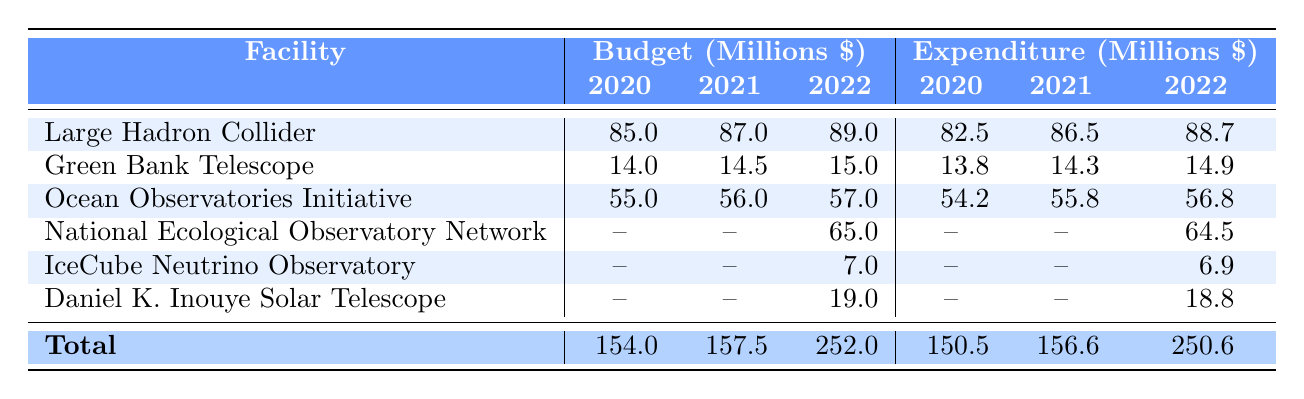What is the budget for the Large Hadron Collider in 2021? The table indicates that the budget for the Large Hadron Collider in 2021 is listed in the corresponding cell under the Budget column for that facility and year, which shows 87.0 million dollars.
Answer: 87.0 million dollars Which facility had the highest expenditure in 2022? By comparing the expenditure values for all facilities in 2022, the Large Hadron Collider has the highest expenditure at 88.7 million dollars.
Answer: Large Hadron Collider What is the total budget allocated for all facilities in 2020? The total budget is obtained by summing the budget values for each facility in 2020, which gives us (85.0 + 14.0 + 55.0) = 154.0 million dollars.
Answer: 154.0 million dollars Did the budget for the Green Bank Telescope increase every year from 2020 to 2022? Looking at the budget values from 2020 to 2022, we see 14.0 in 2020, 14.5 in 2021, and 15.0 in 2022. Each value is greater than the previous year. Thus, the budget did increase every year.
Answer: Yes What is the average expenditure on the Ocean Observatories Initiative over the three years? To calculate the average, we first sum the expenditures for the Ocean Observatories Initiative for 2020, 2021, and 2022: (54.2 + 55.8 + 56.8) = 166.8 million dollars. We then divide this by 3, resulting in an average of 166.8 / 3 = 55.6 million dollars.
Answer: 55.6 million dollars Which category does the National Ecological Observatory Network fall under? The table shows that the National Ecological Observatory Network is categorized under Environmental Science.
Answer: Environmental Science Was the expenditure for the IceCube Neutrino Observatory lower than 7 million dollars in 2022? According to the table, the expenditure for the IceCube Neutrino Observatory in 2022 is recorded at 6.9 million dollars, which is indeed lower than 7 million dollars.
Answer: Yes Which facility had the smallest budget in 2022, and what was that budget? By examining the budgets in 2022, the IceCube Neutrino Observatory had the smallest budget of 7.0 million dollars when compared to the other facilities listed.
Answer: IceCube Neutrino Observatory, 7.0 million dollars How much more was spent on the Large Hadron Collider than on the Green Bank Telescope in 2021? We calculate the difference in expenditure between these two facilities in 2021: 86.5 million (Large Hadron Collider) - 14.3 million (Green Bank Telescope) = 72.2 million dollars more was spent on the Large Hadron Collider.
Answer: 72.2 million dollars 